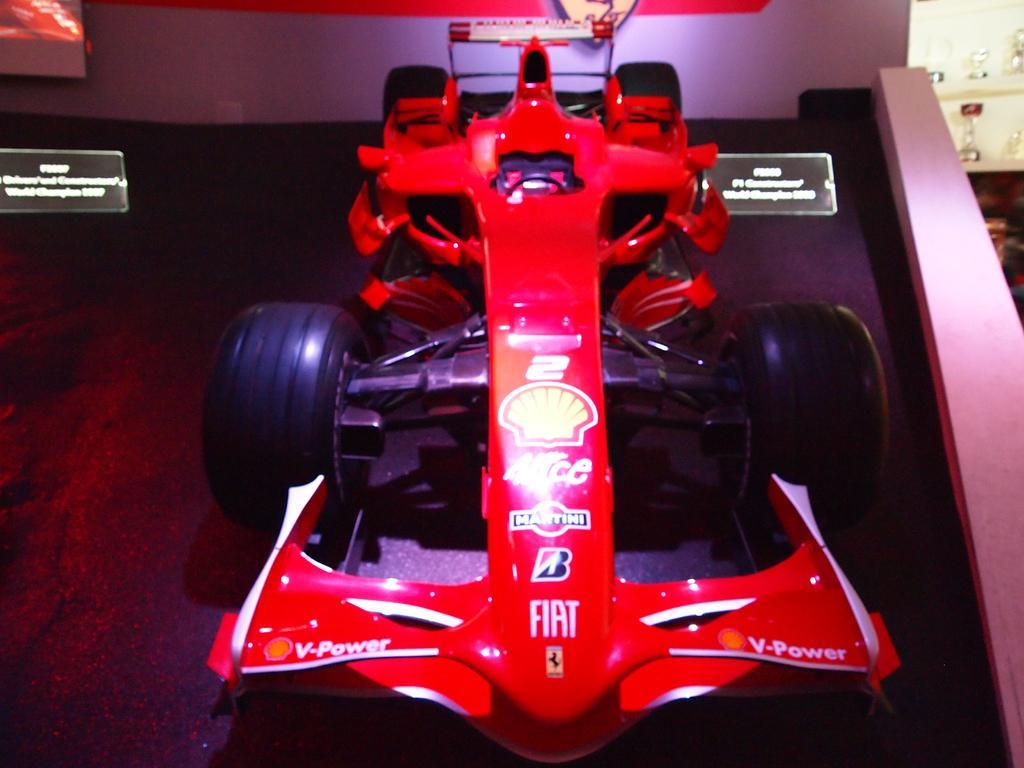Can you describe this image briefly? In this picture there is a car on the floor and we can see boards and wall. In the background of the image we can see objects. 